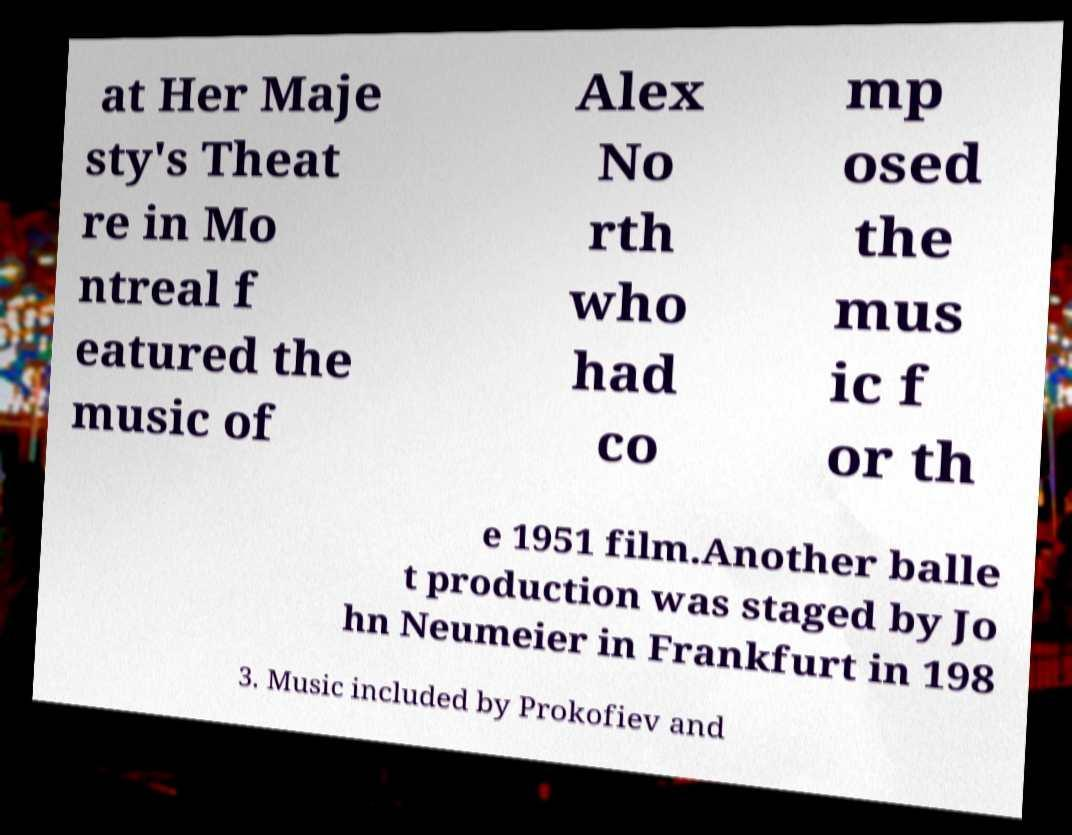What messages or text are displayed in this image? I need them in a readable, typed format. at Her Maje sty's Theat re in Mo ntreal f eatured the music of Alex No rth who had co mp osed the mus ic f or th e 1951 film.Another balle t production was staged by Jo hn Neumeier in Frankfurt in 198 3. Music included by Prokofiev and 